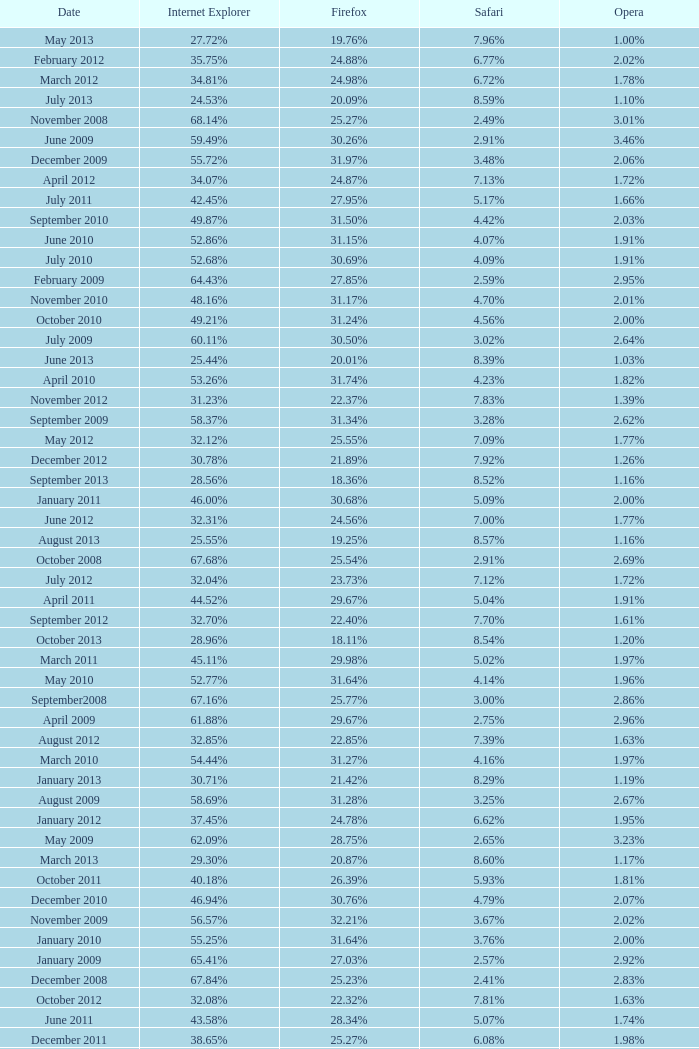What percentage of browsers were using Internet Explorer during the period in which 27.85% were using Firefox? 64.43%. 